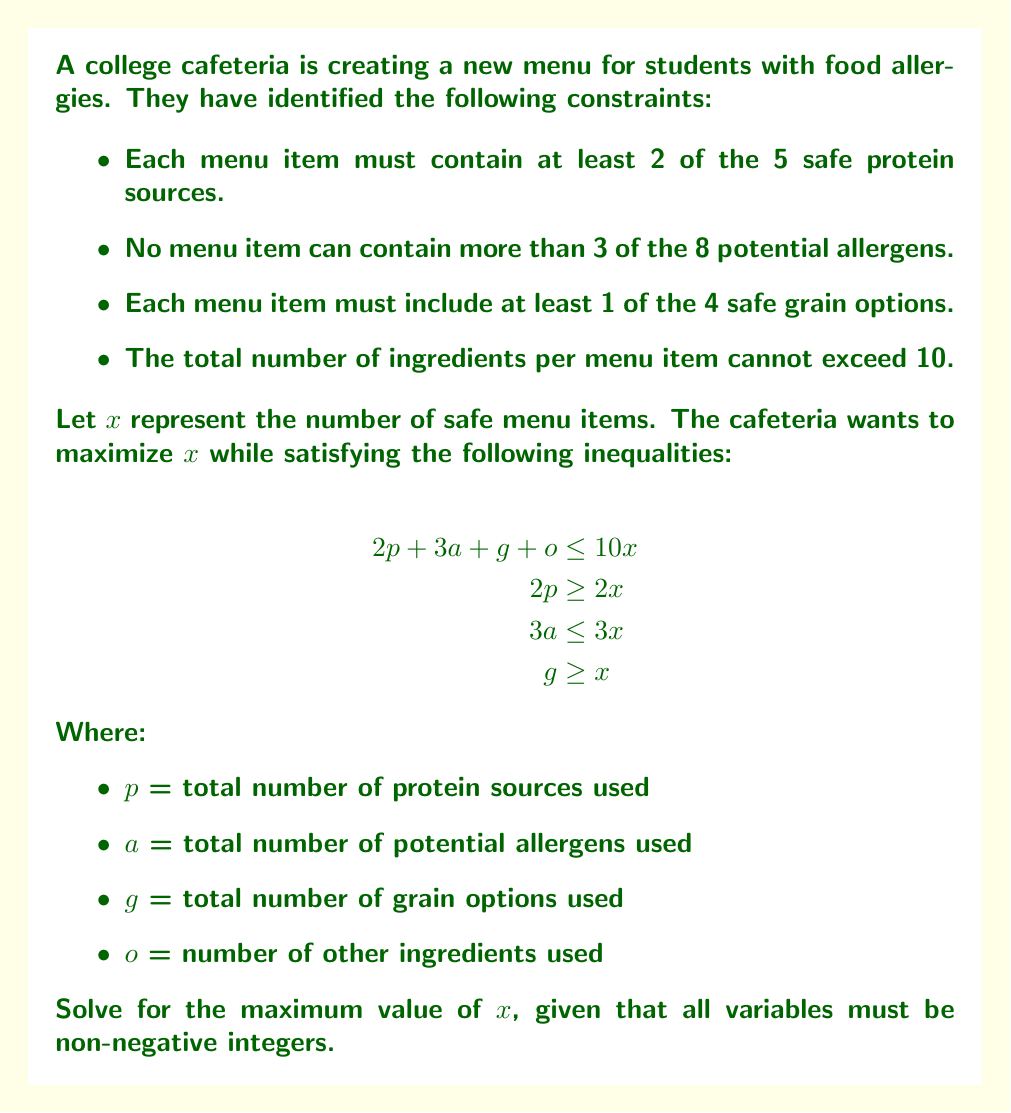Can you answer this question? To solve this problem, we'll follow these steps:

1) First, we need to understand what each inequality represents:
   - $2p + 3a + g + o \leq 10x$ : Total ingredients across all menu items
   - $2p \geq 2x$ : Minimum protein requirement
   - $3a \leq 3x$ : Maximum allergen constraint
   - $g \geq x$ : Minimum grain requirement

2) From $2p \geq 2x$, we can deduce $p \geq x$. This means we need at least as many protein sources as menu items.

3) From $g \geq x$, we know we need at least as many grain options as menu items.

4) Substituting the minimum values for $p$ and $g$ into the first inequality:
   $2x + 3a + x + o \leq 10x$

5) Simplifying:
   $3x + 3a + o \leq 10x$
   $3a + o \leq 7x$

6) We know $3a \leq 3x$ from the given constraints. Substituting this:
   $3x + o \leq 7x$
   $o \leq 4x$

7) Since all variables must be non-negative integers, the maximum value for $x$ will occur when $o = 4x - 1$ (the largest integer value less than $4x$).

8) Substituting this back into the original inequality:
   $2x + 3x + x + (4x - 1) \leq 10x$
   $10x - 1 \leq 10x$

9) This inequality holds for all positive integer values of $x$. However, we need to consider the constraint on $a$ as well. The maximum value of $x$ will occur when $a$ takes its maximum value, which is $x$.

Therefore, the maximum value of $x$ is limited by the number of available ingredients:
- 5 protein sources
- 8 potential allergens
- 4 grain options

The sum of these is 17, which is the upper limit for $x$.
Answer: The maximum number of safe menu items (x) is 17. 